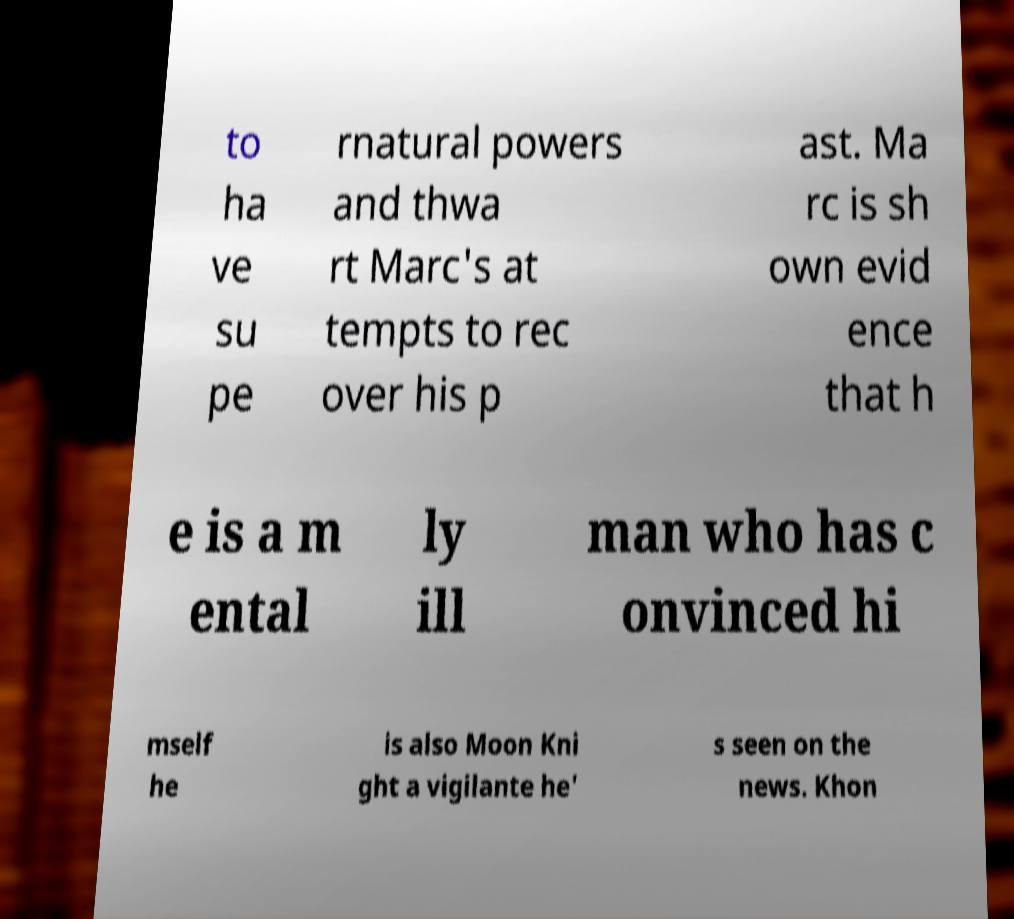What messages or text are displayed in this image? I need them in a readable, typed format. to ha ve su pe rnatural powers and thwa rt Marc's at tempts to rec over his p ast. Ma rc is sh own evid ence that h e is a m ental ly ill man who has c onvinced hi mself he is also Moon Kni ght a vigilante he' s seen on the news. Khon 